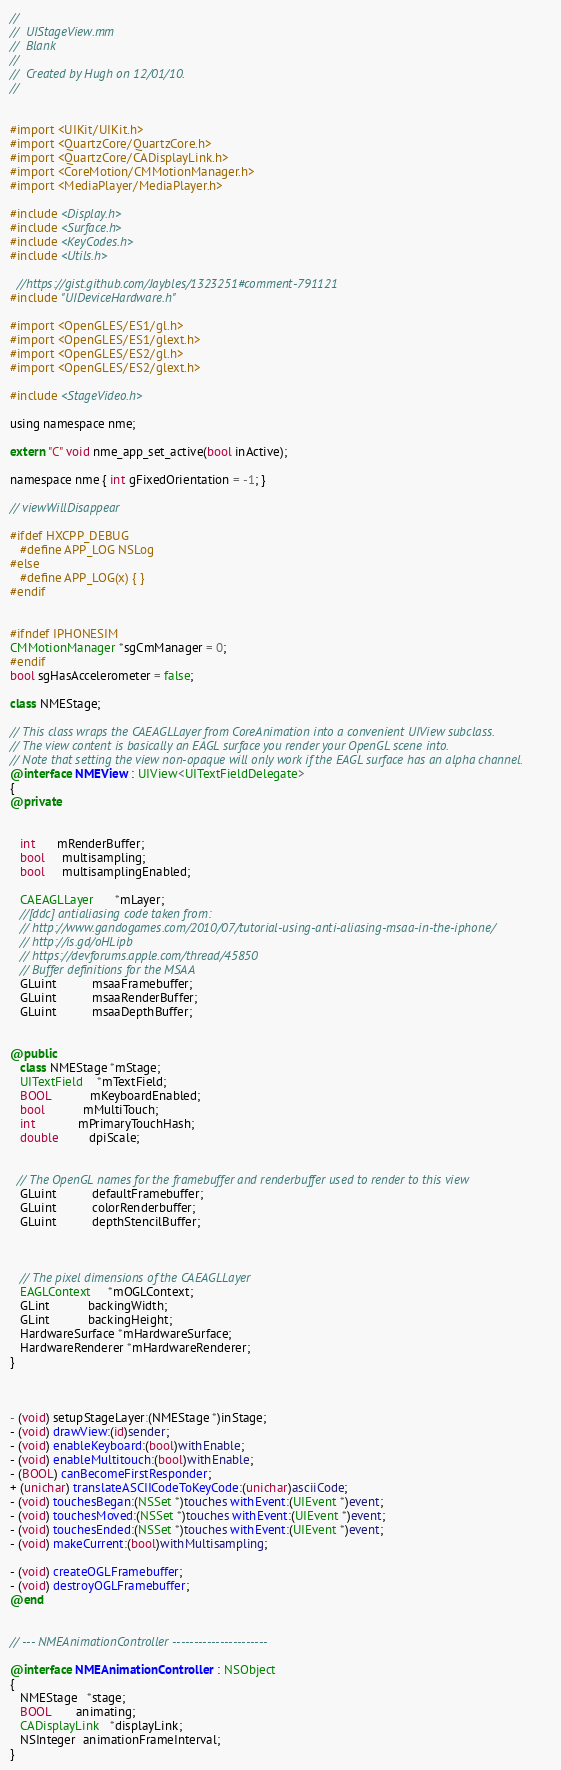<code> <loc_0><loc_0><loc_500><loc_500><_ObjectiveC_>//
//  UIStageView.mm
//  Blank
//
//  Created by Hugh on 12/01/10.
//


#import <UIKit/UIKit.h>
#import <QuartzCore/QuartzCore.h>
#import <QuartzCore/CADisplayLink.h>
#import <CoreMotion/CMMotionManager.h>
#import <MediaPlayer/MediaPlayer.h>

#include <Display.h>
#include <Surface.h>
#include <KeyCodes.h>
#include <Utils.h>

  //https://gist.github.com/Jaybles/1323251#comment-791121
#include "UIDeviceHardware.h"

#import <OpenGLES/ES1/gl.h>
#import <OpenGLES/ES1/glext.h>
#import <OpenGLES/ES2/gl.h>
#import <OpenGLES/ES2/glext.h>

#include <StageVideo.h>

using namespace nme;

extern "C" void nme_app_set_active(bool inActive);

namespace nme { int gFixedOrientation = -1; }

// viewWillDisappear

#ifdef HXCPP_DEBUG
   #define APP_LOG NSLog
#else
   #define APP_LOG(x) { }
#endif


#ifndef IPHONESIM
CMMotionManager *sgCmManager = 0;
#endif
bool sgHasAccelerometer = false;

class NMEStage;

// This class wraps the CAEAGLLayer from CoreAnimation into a convenient UIView subclass.
// The view content is basically an EAGL surface you render your OpenGL scene into.
// Note that setting the view non-opaque will only work if the EAGL surface has an alpha channel.
@interface NMEView : UIView<UITextFieldDelegate>
{    
@private


   int      mRenderBuffer;
   bool     multisampling;
   bool     multisamplingEnabled;

   CAEAGLLayer      *mLayer;
   //[ddc] antialiasing code taken from:
   // http://www.gandogames.com/2010/07/tutorial-using-anti-aliasing-msaa-in-the-iphone/
   // http://is.gd/oHLipb
   // https://devforums.apple.com/thread/45850
   // Buffer definitions for the MSAA
   GLuint          msaaFramebuffer;
   GLuint          msaaRenderBuffer;
   GLuint          msaaDepthBuffer;


@public
   class NMEStage *mStage;
   UITextField    *mTextField;
   BOOL           mKeyboardEnabled;
   bool           mMultiTouch;
   int            mPrimaryTouchHash;
   double         dpiScale;


  // The OpenGL names for the framebuffer and renderbuffer used to render to this view
   GLuint          defaultFramebuffer;
   GLuint          colorRenderbuffer;
   GLuint          depthStencilBuffer;



   // The pixel dimensions of the CAEAGLLayer
   EAGLContext     *mOGLContext;
   GLint           backingWidth;
   GLint           backingHeight;
   HardwareSurface *mHardwareSurface;
   HardwareRenderer *mHardwareRenderer;
}



- (void) setupStageLayer:(NMEStage *)inStage;
- (void) drawView:(id)sender;
- (void) enableKeyboard:(bool)withEnable;
- (void) enableMultitouch:(bool)withEnable;
- (BOOL) canBecomeFirstResponder;
+ (unichar) translateASCIICodeToKeyCode:(unichar)asciiCode;
- (void) touchesBegan:(NSSet *)touches withEvent:(UIEvent *)event;
- (void) touchesMoved:(NSSet *)touches withEvent:(UIEvent *)event;
- (void) touchesEnded:(NSSet *)touches withEvent:(UIEvent *)event;
- (void) makeCurrent:(bool)withMultisampling;

- (void) createOGLFramebuffer;
- (void) destroyOGLFramebuffer;
@end


// --- NMEAnimationController ----------------------

@interface NMEAnimationController : NSObject
{
   NMEStage   *stage;
   BOOL       animating;
   CADisplayLink   *displayLink;
   NSInteger  animationFrameInterval;
}</code> 